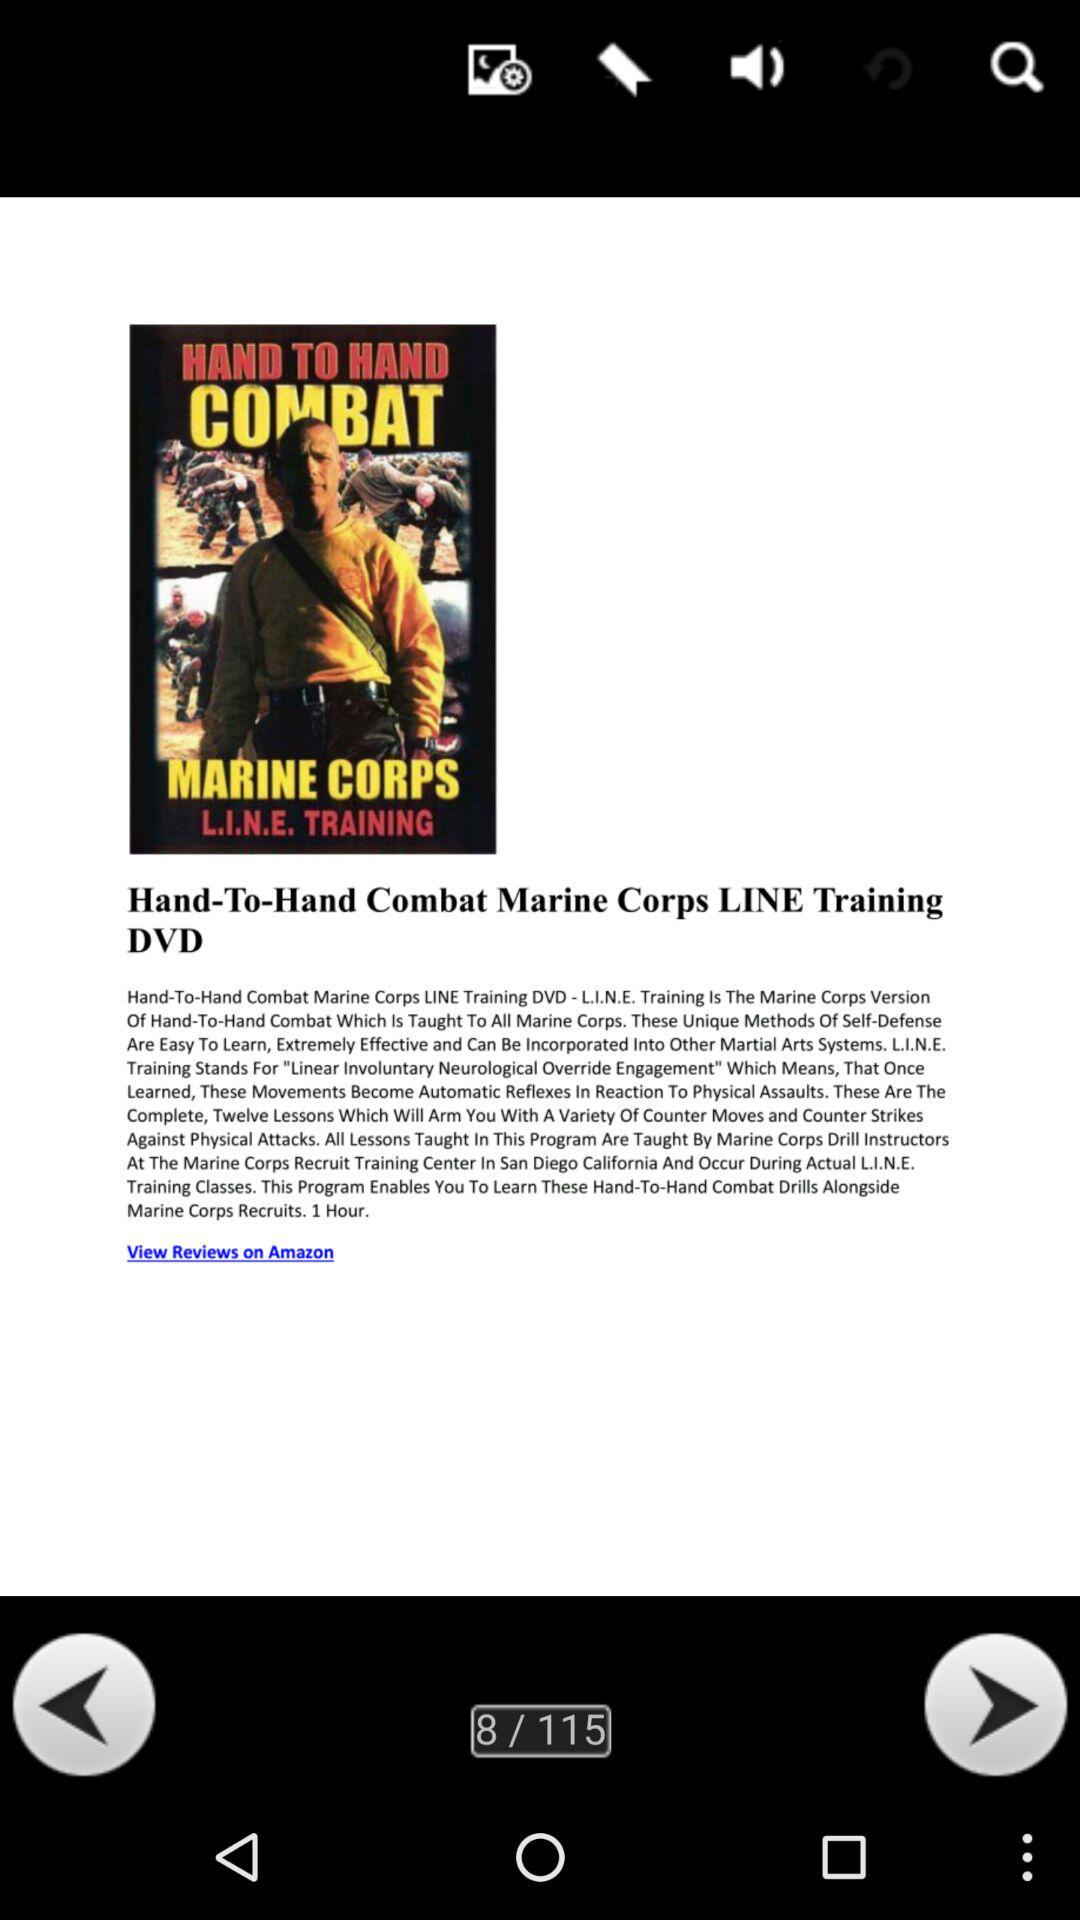What is the title? The title is "Hand-To-Hand Combat Marine Corps LINE Training DVD". 